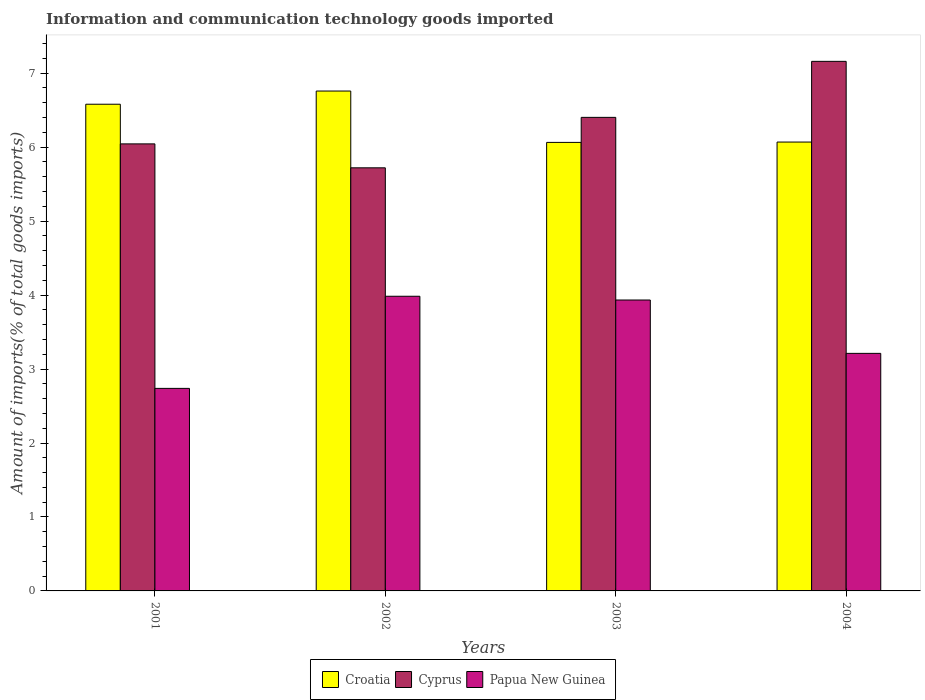How many different coloured bars are there?
Provide a succinct answer. 3. How many groups of bars are there?
Ensure brevity in your answer.  4. Are the number of bars on each tick of the X-axis equal?
Your answer should be compact. Yes. How many bars are there on the 2nd tick from the right?
Your response must be concise. 3. What is the label of the 4th group of bars from the left?
Offer a very short reply. 2004. In how many cases, is the number of bars for a given year not equal to the number of legend labels?
Offer a very short reply. 0. What is the amount of goods imported in Croatia in 2001?
Provide a succinct answer. 6.58. Across all years, what is the maximum amount of goods imported in Croatia?
Provide a succinct answer. 6.76. Across all years, what is the minimum amount of goods imported in Croatia?
Your answer should be compact. 6.06. In which year was the amount of goods imported in Papua New Guinea maximum?
Provide a succinct answer. 2002. In which year was the amount of goods imported in Croatia minimum?
Offer a terse response. 2003. What is the total amount of goods imported in Cyprus in the graph?
Keep it short and to the point. 25.33. What is the difference between the amount of goods imported in Papua New Guinea in 2002 and that in 2003?
Offer a terse response. 0.05. What is the difference between the amount of goods imported in Papua New Guinea in 2001 and the amount of goods imported in Cyprus in 2002?
Your answer should be compact. -2.98. What is the average amount of goods imported in Cyprus per year?
Provide a succinct answer. 6.33. In the year 2004, what is the difference between the amount of goods imported in Cyprus and amount of goods imported in Croatia?
Provide a succinct answer. 1.09. In how many years, is the amount of goods imported in Papua New Guinea greater than 1.6 %?
Your answer should be very brief. 4. What is the ratio of the amount of goods imported in Cyprus in 2002 to that in 2003?
Offer a very short reply. 0.89. Is the difference between the amount of goods imported in Cyprus in 2001 and 2004 greater than the difference between the amount of goods imported in Croatia in 2001 and 2004?
Offer a terse response. No. What is the difference between the highest and the second highest amount of goods imported in Cyprus?
Offer a very short reply. 0.76. What is the difference between the highest and the lowest amount of goods imported in Croatia?
Ensure brevity in your answer.  0.69. What does the 3rd bar from the left in 2001 represents?
Your answer should be compact. Papua New Guinea. What does the 1st bar from the right in 2001 represents?
Your answer should be very brief. Papua New Guinea. How many bars are there?
Provide a short and direct response. 12. Are all the bars in the graph horizontal?
Keep it short and to the point. No. How many years are there in the graph?
Your response must be concise. 4. Does the graph contain grids?
Offer a terse response. No. Where does the legend appear in the graph?
Give a very brief answer. Bottom center. How are the legend labels stacked?
Offer a terse response. Horizontal. What is the title of the graph?
Offer a terse response. Information and communication technology goods imported. What is the label or title of the X-axis?
Offer a terse response. Years. What is the label or title of the Y-axis?
Keep it short and to the point. Amount of imports(% of total goods imports). What is the Amount of imports(% of total goods imports) of Croatia in 2001?
Keep it short and to the point. 6.58. What is the Amount of imports(% of total goods imports) of Cyprus in 2001?
Give a very brief answer. 6.04. What is the Amount of imports(% of total goods imports) in Papua New Guinea in 2001?
Provide a succinct answer. 2.74. What is the Amount of imports(% of total goods imports) of Croatia in 2002?
Provide a short and direct response. 6.76. What is the Amount of imports(% of total goods imports) of Cyprus in 2002?
Your answer should be compact. 5.72. What is the Amount of imports(% of total goods imports) of Papua New Guinea in 2002?
Your answer should be compact. 3.98. What is the Amount of imports(% of total goods imports) of Croatia in 2003?
Offer a terse response. 6.06. What is the Amount of imports(% of total goods imports) in Cyprus in 2003?
Your answer should be compact. 6.4. What is the Amount of imports(% of total goods imports) of Papua New Guinea in 2003?
Make the answer very short. 3.93. What is the Amount of imports(% of total goods imports) in Croatia in 2004?
Make the answer very short. 6.07. What is the Amount of imports(% of total goods imports) of Cyprus in 2004?
Offer a terse response. 7.16. What is the Amount of imports(% of total goods imports) of Papua New Guinea in 2004?
Your response must be concise. 3.21. Across all years, what is the maximum Amount of imports(% of total goods imports) of Croatia?
Offer a terse response. 6.76. Across all years, what is the maximum Amount of imports(% of total goods imports) of Cyprus?
Make the answer very short. 7.16. Across all years, what is the maximum Amount of imports(% of total goods imports) in Papua New Guinea?
Your answer should be very brief. 3.98. Across all years, what is the minimum Amount of imports(% of total goods imports) in Croatia?
Offer a very short reply. 6.06. Across all years, what is the minimum Amount of imports(% of total goods imports) of Cyprus?
Provide a short and direct response. 5.72. Across all years, what is the minimum Amount of imports(% of total goods imports) of Papua New Guinea?
Your response must be concise. 2.74. What is the total Amount of imports(% of total goods imports) in Croatia in the graph?
Provide a succinct answer. 25.47. What is the total Amount of imports(% of total goods imports) in Cyprus in the graph?
Provide a short and direct response. 25.33. What is the total Amount of imports(% of total goods imports) of Papua New Guinea in the graph?
Your answer should be very brief. 13.87. What is the difference between the Amount of imports(% of total goods imports) in Croatia in 2001 and that in 2002?
Provide a short and direct response. -0.18. What is the difference between the Amount of imports(% of total goods imports) in Cyprus in 2001 and that in 2002?
Ensure brevity in your answer.  0.32. What is the difference between the Amount of imports(% of total goods imports) of Papua New Guinea in 2001 and that in 2002?
Provide a short and direct response. -1.25. What is the difference between the Amount of imports(% of total goods imports) of Croatia in 2001 and that in 2003?
Ensure brevity in your answer.  0.52. What is the difference between the Amount of imports(% of total goods imports) of Cyprus in 2001 and that in 2003?
Provide a succinct answer. -0.36. What is the difference between the Amount of imports(% of total goods imports) in Papua New Guinea in 2001 and that in 2003?
Provide a short and direct response. -1.19. What is the difference between the Amount of imports(% of total goods imports) of Croatia in 2001 and that in 2004?
Keep it short and to the point. 0.51. What is the difference between the Amount of imports(% of total goods imports) in Cyprus in 2001 and that in 2004?
Your response must be concise. -1.12. What is the difference between the Amount of imports(% of total goods imports) in Papua New Guinea in 2001 and that in 2004?
Offer a very short reply. -0.47. What is the difference between the Amount of imports(% of total goods imports) in Croatia in 2002 and that in 2003?
Make the answer very short. 0.69. What is the difference between the Amount of imports(% of total goods imports) of Cyprus in 2002 and that in 2003?
Your response must be concise. -0.68. What is the difference between the Amount of imports(% of total goods imports) in Papua New Guinea in 2002 and that in 2003?
Ensure brevity in your answer.  0.05. What is the difference between the Amount of imports(% of total goods imports) in Croatia in 2002 and that in 2004?
Your answer should be very brief. 0.69. What is the difference between the Amount of imports(% of total goods imports) in Cyprus in 2002 and that in 2004?
Make the answer very short. -1.44. What is the difference between the Amount of imports(% of total goods imports) in Papua New Guinea in 2002 and that in 2004?
Offer a very short reply. 0.77. What is the difference between the Amount of imports(% of total goods imports) in Croatia in 2003 and that in 2004?
Offer a very short reply. -0. What is the difference between the Amount of imports(% of total goods imports) in Cyprus in 2003 and that in 2004?
Ensure brevity in your answer.  -0.76. What is the difference between the Amount of imports(% of total goods imports) of Papua New Guinea in 2003 and that in 2004?
Provide a short and direct response. 0.72. What is the difference between the Amount of imports(% of total goods imports) in Croatia in 2001 and the Amount of imports(% of total goods imports) in Cyprus in 2002?
Your answer should be compact. 0.86. What is the difference between the Amount of imports(% of total goods imports) of Croatia in 2001 and the Amount of imports(% of total goods imports) of Papua New Guinea in 2002?
Provide a succinct answer. 2.6. What is the difference between the Amount of imports(% of total goods imports) in Cyprus in 2001 and the Amount of imports(% of total goods imports) in Papua New Guinea in 2002?
Ensure brevity in your answer.  2.06. What is the difference between the Amount of imports(% of total goods imports) of Croatia in 2001 and the Amount of imports(% of total goods imports) of Cyprus in 2003?
Provide a succinct answer. 0.18. What is the difference between the Amount of imports(% of total goods imports) in Croatia in 2001 and the Amount of imports(% of total goods imports) in Papua New Guinea in 2003?
Offer a very short reply. 2.65. What is the difference between the Amount of imports(% of total goods imports) of Cyprus in 2001 and the Amount of imports(% of total goods imports) of Papua New Guinea in 2003?
Ensure brevity in your answer.  2.11. What is the difference between the Amount of imports(% of total goods imports) of Croatia in 2001 and the Amount of imports(% of total goods imports) of Cyprus in 2004?
Give a very brief answer. -0.58. What is the difference between the Amount of imports(% of total goods imports) of Croatia in 2001 and the Amount of imports(% of total goods imports) of Papua New Guinea in 2004?
Offer a terse response. 3.37. What is the difference between the Amount of imports(% of total goods imports) in Cyprus in 2001 and the Amount of imports(% of total goods imports) in Papua New Guinea in 2004?
Your response must be concise. 2.83. What is the difference between the Amount of imports(% of total goods imports) of Croatia in 2002 and the Amount of imports(% of total goods imports) of Cyprus in 2003?
Provide a succinct answer. 0.36. What is the difference between the Amount of imports(% of total goods imports) in Croatia in 2002 and the Amount of imports(% of total goods imports) in Papua New Guinea in 2003?
Give a very brief answer. 2.83. What is the difference between the Amount of imports(% of total goods imports) of Cyprus in 2002 and the Amount of imports(% of total goods imports) of Papua New Guinea in 2003?
Provide a succinct answer. 1.79. What is the difference between the Amount of imports(% of total goods imports) in Croatia in 2002 and the Amount of imports(% of total goods imports) in Cyprus in 2004?
Your response must be concise. -0.4. What is the difference between the Amount of imports(% of total goods imports) in Croatia in 2002 and the Amount of imports(% of total goods imports) in Papua New Guinea in 2004?
Your answer should be compact. 3.55. What is the difference between the Amount of imports(% of total goods imports) in Cyprus in 2002 and the Amount of imports(% of total goods imports) in Papua New Guinea in 2004?
Offer a very short reply. 2.51. What is the difference between the Amount of imports(% of total goods imports) of Croatia in 2003 and the Amount of imports(% of total goods imports) of Cyprus in 2004?
Offer a very short reply. -1.1. What is the difference between the Amount of imports(% of total goods imports) in Croatia in 2003 and the Amount of imports(% of total goods imports) in Papua New Guinea in 2004?
Offer a very short reply. 2.85. What is the difference between the Amount of imports(% of total goods imports) of Cyprus in 2003 and the Amount of imports(% of total goods imports) of Papua New Guinea in 2004?
Provide a short and direct response. 3.19. What is the average Amount of imports(% of total goods imports) of Croatia per year?
Your answer should be compact. 6.37. What is the average Amount of imports(% of total goods imports) of Cyprus per year?
Offer a terse response. 6.33. What is the average Amount of imports(% of total goods imports) in Papua New Guinea per year?
Keep it short and to the point. 3.47. In the year 2001, what is the difference between the Amount of imports(% of total goods imports) in Croatia and Amount of imports(% of total goods imports) in Cyprus?
Make the answer very short. 0.54. In the year 2001, what is the difference between the Amount of imports(% of total goods imports) of Croatia and Amount of imports(% of total goods imports) of Papua New Guinea?
Provide a short and direct response. 3.84. In the year 2001, what is the difference between the Amount of imports(% of total goods imports) in Cyprus and Amount of imports(% of total goods imports) in Papua New Guinea?
Your response must be concise. 3.31. In the year 2002, what is the difference between the Amount of imports(% of total goods imports) in Croatia and Amount of imports(% of total goods imports) in Cyprus?
Offer a terse response. 1.04. In the year 2002, what is the difference between the Amount of imports(% of total goods imports) in Croatia and Amount of imports(% of total goods imports) in Papua New Guinea?
Your answer should be compact. 2.77. In the year 2002, what is the difference between the Amount of imports(% of total goods imports) in Cyprus and Amount of imports(% of total goods imports) in Papua New Guinea?
Provide a short and direct response. 1.74. In the year 2003, what is the difference between the Amount of imports(% of total goods imports) in Croatia and Amount of imports(% of total goods imports) in Cyprus?
Give a very brief answer. -0.34. In the year 2003, what is the difference between the Amount of imports(% of total goods imports) of Croatia and Amount of imports(% of total goods imports) of Papua New Guinea?
Your response must be concise. 2.13. In the year 2003, what is the difference between the Amount of imports(% of total goods imports) of Cyprus and Amount of imports(% of total goods imports) of Papua New Guinea?
Keep it short and to the point. 2.47. In the year 2004, what is the difference between the Amount of imports(% of total goods imports) in Croatia and Amount of imports(% of total goods imports) in Cyprus?
Provide a short and direct response. -1.09. In the year 2004, what is the difference between the Amount of imports(% of total goods imports) in Croatia and Amount of imports(% of total goods imports) in Papua New Guinea?
Provide a succinct answer. 2.86. In the year 2004, what is the difference between the Amount of imports(% of total goods imports) in Cyprus and Amount of imports(% of total goods imports) in Papua New Guinea?
Provide a succinct answer. 3.95. What is the ratio of the Amount of imports(% of total goods imports) in Croatia in 2001 to that in 2002?
Offer a terse response. 0.97. What is the ratio of the Amount of imports(% of total goods imports) in Cyprus in 2001 to that in 2002?
Offer a terse response. 1.06. What is the ratio of the Amount of imports(% of total goods imports) of Papua New Guinea in 2001 to that in 2002?
Keep it short and to the point. 0.69. What is the ratio of the Amount of imports(% of total goods imports) in Croatia in 2001 to that in 2003?
Give a very brief answer. 1.09. What is the ratio of the Amount of imports(% of total goods imports) of Cyprus in 2001 to that in 2003?
Provide a succinct answer. 0.94. What is the ratio of the Amount of imports(% of total goods imports) in Papua New Guinea in 2001 to that in 2003?
Offer a very short reply. 0.7. What is the ratio of the Amount of imports(% of total goods imports) in Croatia in 2001 to that in 2004?
Your answer should be very brief. 1.08. What is the ratio of the Amount of imports(% of total goods imports) of Cyprus in 2001 to that in 2004?
Keep it short and to the point. 0.84. What is the ratio of the Amount of imports(% of total goods imports) of Papua New Guinea in 2001 to that in 2004?
Your response must be concise. 0.85. What is the ratio of the Amount of imports(% of total goods imports) in Croatia in 2002 to that in 2003?
Keep it short and to the point. 1.11. What is the ratio of the Amount of imports(% of total goods imports) in Cyprus in 2002 to that in 2003?
Keep it short and to the point. 0.89. What is the ratio of the Amount of imports(% of total goods imports) of Papua New Guinea in 2002 to that in 2003?
Keep it short and to the point. 1.01. What is the ratio of the Amount of imports(% of total goods imports) in Croatia in 2002 to that in 2004?
Provide a succinct answer. 1.11. What is the ratio of the Amount of imports(% of total goods imports) in Cyprus in 2002 to that in 2004?
Ensure brevity in your answer.  0.8. What is the ratio of the Amount of imports(% of total goods imports) of Papua New Guinea in 2002 to that in 2004?
Your answer should be very brief. 1.24. What is the ratio of the Amount of imports(% of total goods imports) in Croatia in 2003 to that in 2004?
Offer a terse response. 1. What is the ratio of the Amount of imports(% of total goods imports) of Cyprus in 2003 to that in 2004?
Keep it short and to the point. 0.89. What is the ratio of the Amount of imports(% of total goods imports) of Papua New Guinea in 2003 to that in 2004?
Offer a very short reply. 1.22. What is the difference between the highest and the second highest Amount of imports(% of total goods imports) in Croatia?
Offer a very short reply. 0.18. What is the difference between the highest and the second highest Amount of imports(% of total goods imports) in Cyprus?
Keep it short and to the point. 0.76. What is the difference between the highest and the second highest Amount of imports(% of total goods imports) of Papua New Guinea?
Give a very brief answer. 0.05. What is the difference between the highest and the lowest Amount of imports(% of total goods imports) in Croatia?
Offer a terse response. 0.69. What is the difference between the highest and the lowest Amount of imports(% of total goods imports) of Cyprus?
Provide a short and direct response. 1.44. What is the difference between the highest and the lowest Amount of imports(% of total goods imports) in Papua New Guinea?
Offer a terse response. 1.25. 